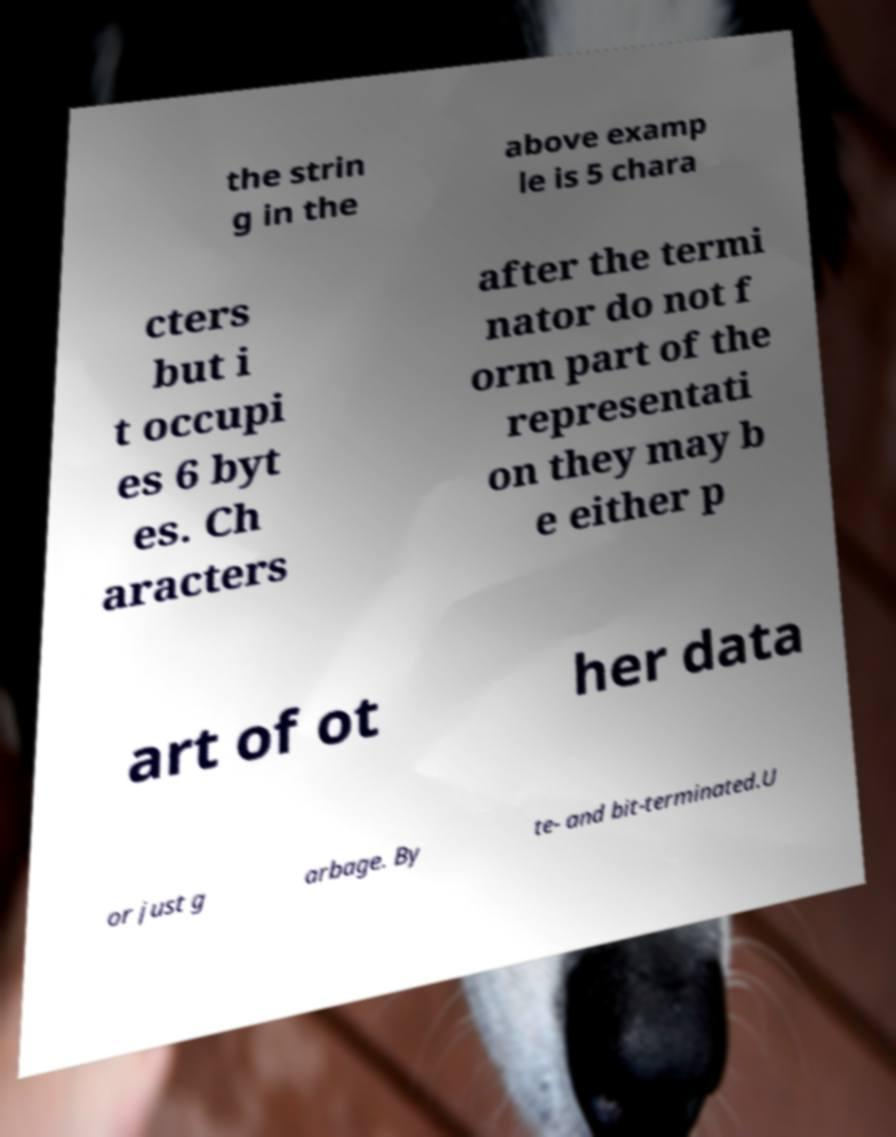Can you read and provide the text displayed in the image?This photo seems to have some interesting text. Can you extract and type it out for me? the strin g in the above examp le is 5 chara cters but i t occupi es 6 byt es. Ch aracters after the termi nator do not f orm part of the representati on they may b e either p art of ot her data or just g arbage. By te- and bit-terminated.U 